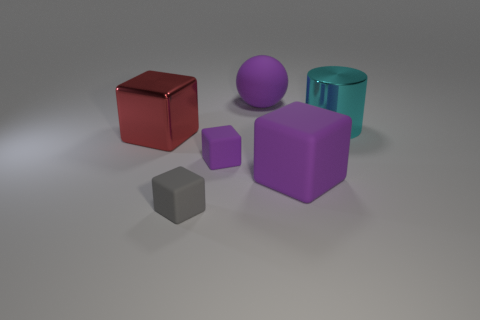Add 3 large purple cubes. How many objects exist? 9 Subtract all cubes. How many objects are left? 2 Subtract all metallic objects. Subtract all large metallic things. How many objects are left? 2 Add 5 purple matte spheres. How many purple matte spheres are left? 6 Add 6 green metal balls. How many green metal balls exist? 6 Subtract 0 brown cylinders. How many objects are left? 6 